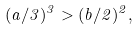Convert formula to latex. <formula><loc_0><loc_0><loc_500><loc_500>( a / 3 ) ^ { 3 } > ( b / 2 ) ^ { 2 } ,</formula> 